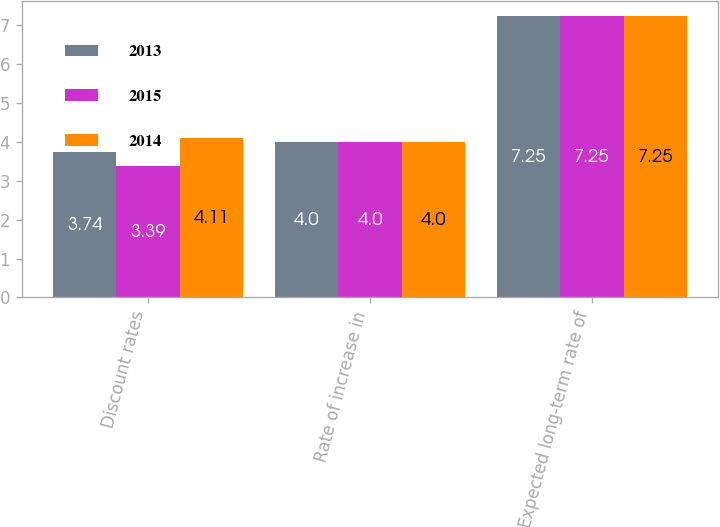Convert chart. <chart><loc_0><loc_0><loc_500><loc_500><stacked_bar_chart><ecel><fcel>Discount rates<fcel>Rate of increase in<fcel>Expected long-term rate of<nl><fcel>2013<fcel>3.74<fcel>4<fcel>7.25<nl><fcel>2015<fcel>3.39<fcel>4<fcel>7.25<nl><fcel>2014<fcel>4.11<fcel>4<fcel>7.25<nl></chart> 